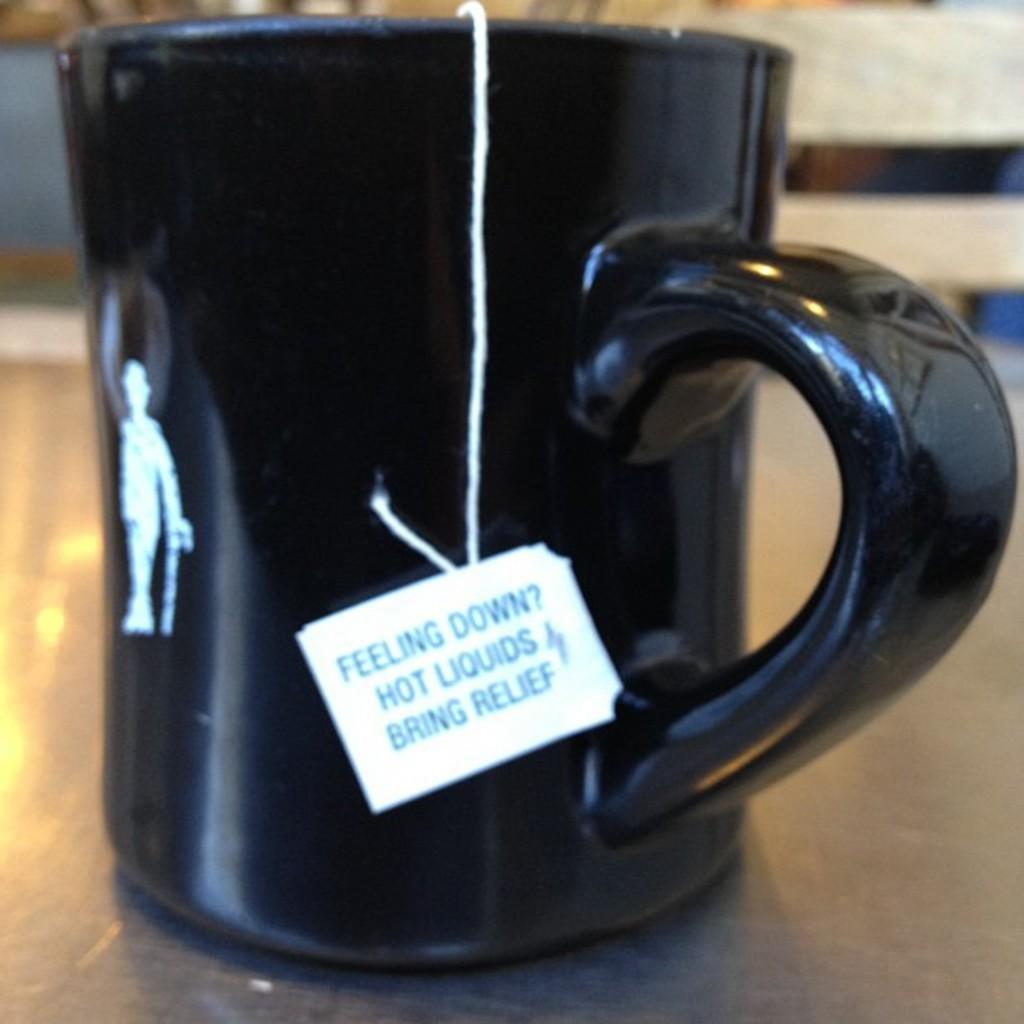Could you give a brief overview of what you see in this image? In this picture we can see a cup and a tag on a platform. There is a blur background. 